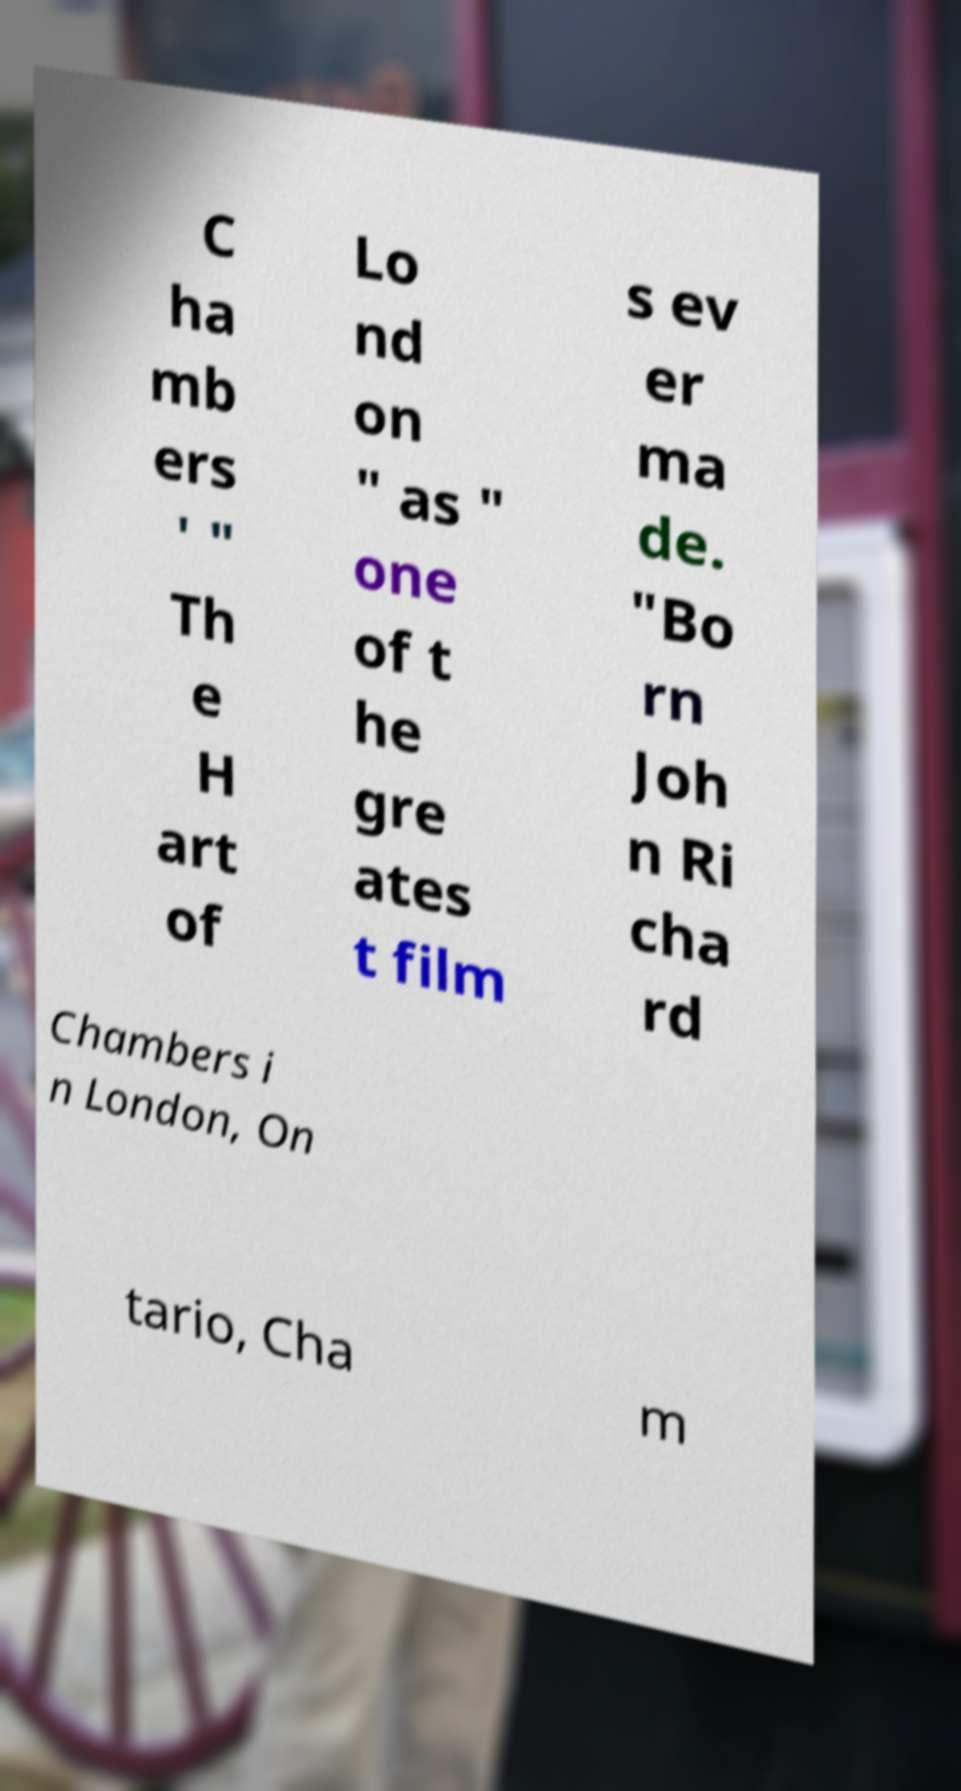Could you assist in decoding the text presented in this image and type it out clearly? C ha mb ers ' " Th e H art of Lo nd on " as " one of t he gre ates t film s ev er ma de. "Bo rn Joh n Ri cha rd Chambers i n London, On tario, Cha m 